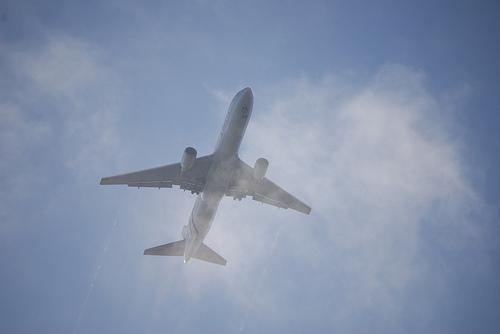How many planes flying?
Give a very brief answer. 1. 